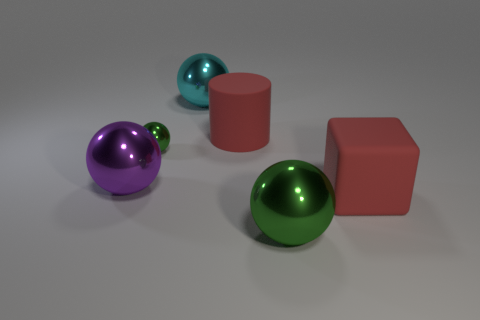Subtract all purple metal spheres. How many spheres are left? 3 Subtract 1 blocks. How many blocks are left? 0 Add 4 red cubes. How many objects exist? 10 Subtract all purple balls. How many balls are left? 3 Subtract 0 purple cylinders. How many objects are left? 6 Subtract all cylinders. How many objects are left? 5 Subtract all gray cylinders. Subtract all purple cubes. How many cylinders are left? 1 Subtract all blue cubes. How many purple spheres are left? 1 Subtract all cyan rubber objects. Subtract all big purple metallic things. How many objects are left? 5 Add 5 large purple balls. How many large purple balls are left? 6 